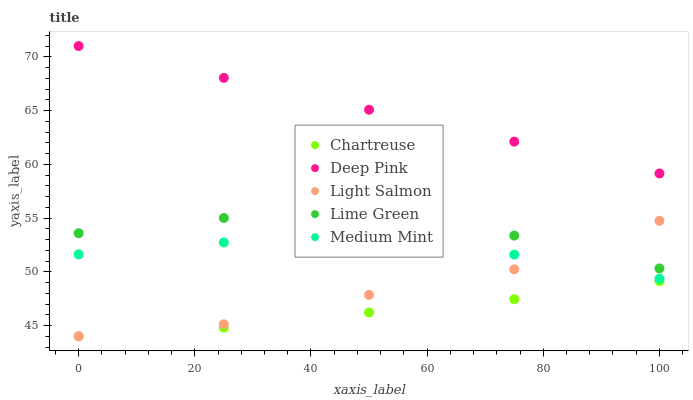Does Chartreuse have the minimum area under the curve?
Answer yes or no. Yes. Does Deep Pink have the maximum area under the curve?
Answer yes or no. Yes. Does Deep Pink have the minimum area under the curve?
Answer yes or no. No. Does Chartreuse have the maximum area under the curve?
Answer yes or no. No. Is Deep Pink the smoothest?
Answer yes or no. Yes. Is Lime Green the roughest?
Answer yes or no. Yes. Is Chartreuse the smoothest?
Answer yes or no. No. Is Chartreuse the roughest?
Answer yes or no. No. Does Chartreuse have the lowest value?
Answer yes or no. Yes. Does Deep Pink have the lowest value?
Answer yes or no. No. Does Deep Pink have the highest value?
Answer yes or no. Yes. Does Chartreuse have the highest value?
Answer yes or no. No. Is Medium Mint less than Deep Pink?
Answer yes or no. Yes. Is Deep Pink greater than Light Salmon?
Answer yes or no. Yes. Does Light Salmon intersect Medium Mint?
Answer yes or no. Yes. Is Light Salmon less than Medium Mint?
Answer yes or no. No. Is Light Salmon greater than Medium Mint?
Answer yes or no. No. Does Medium Mint intersect Deep Pink?
Answer yes or no. No. 